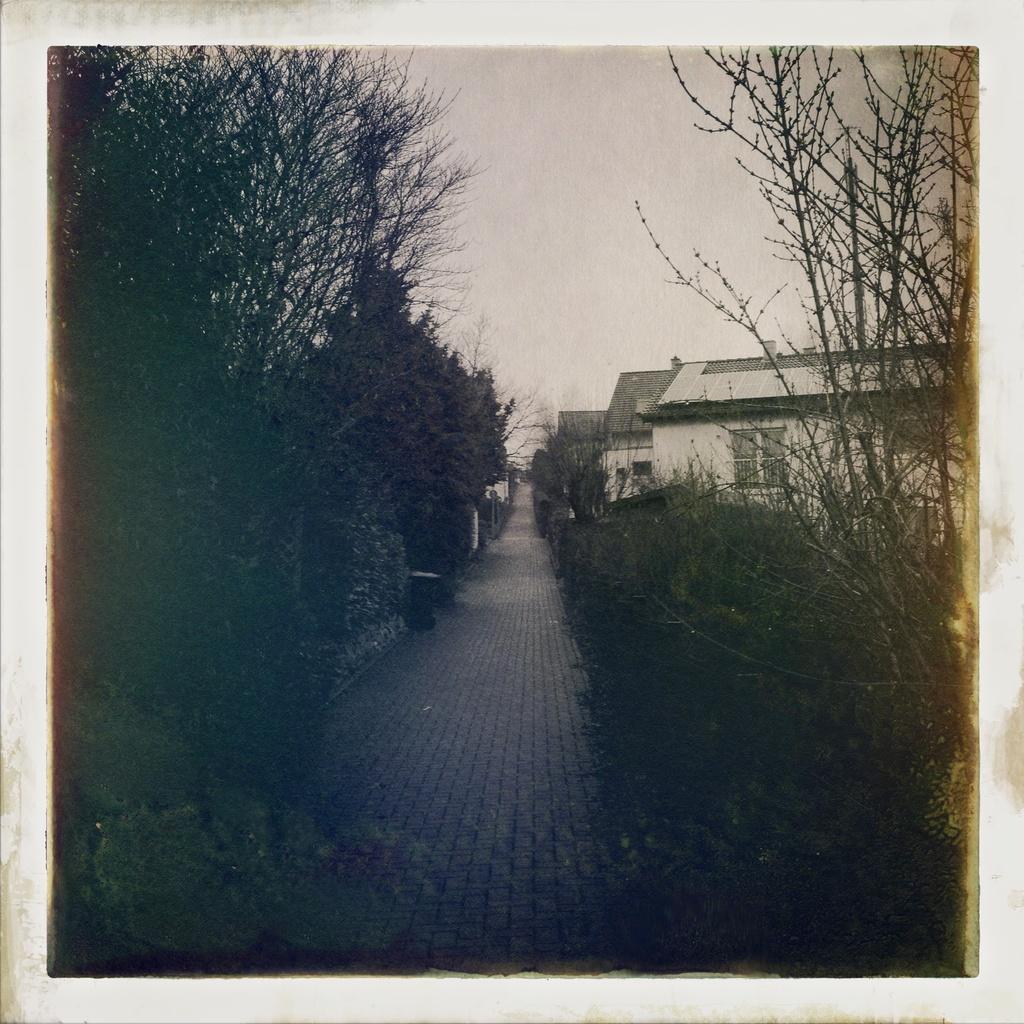Describe this image in one or two sentences. This image consists of plants and trees and in the background there are houses. 